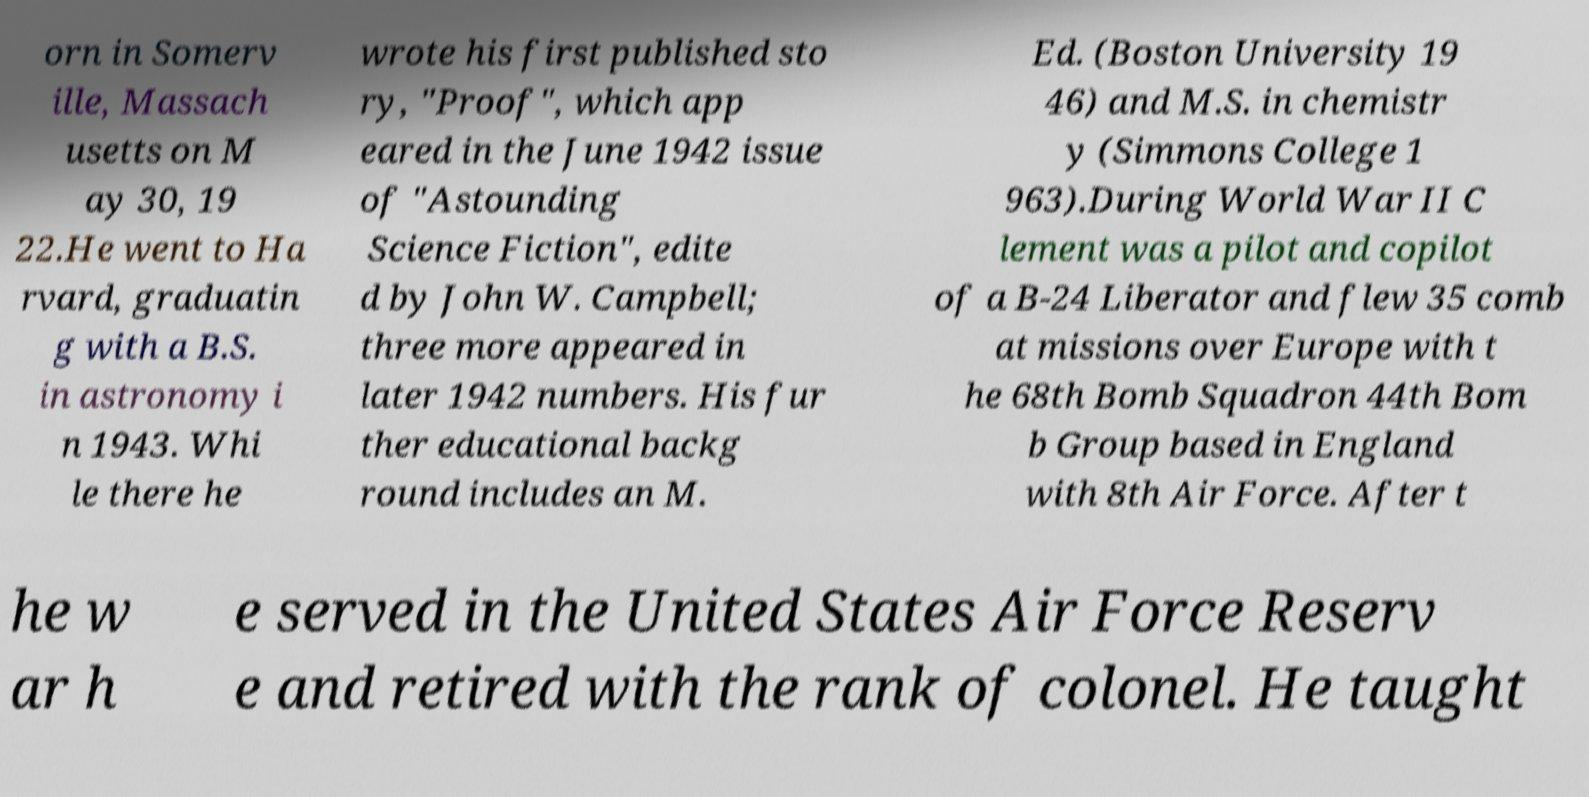Can you read and provide the text displayed in the image?This photo seems to have some interesting text. Can you extract and type it out for me? orn in Somerv ille, Massach usetts on M ay 30, 19 22.He went to Ha rvard, graduatin g with a B.S. in astronomy i n 1943. Whi le there he wrote his first published sto ry, "Proof", which app eared in the June 1942 issue of "Astounding Science Fiction", edite d by John W. Campbell; three more appeared in later 1942 numbers. His fur ther educational backg round includes an M. Ed. (Boston University 19 46) and M.S. in chemistr y (Simmons College 1 963).During World War II C lement was a pilot and copilot of a B-24 Liberator and flew 35 comb at missions over Europe with t he 68th Bomb Squadron 44th Bom b Group based in England with 8th Air Force. After t he w ar h e served in the United States Air Force Reserv e and retired with the rank of colonel. He taught 